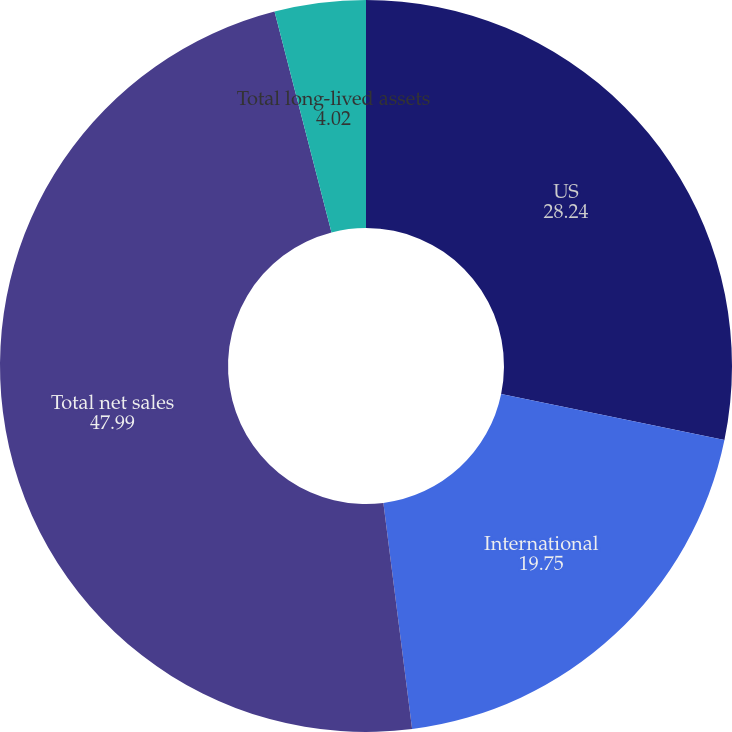Convert chart to OTSL. <chart><loc_0><loc_0><loc_500><loc_500><pie_chart><fcel>US<fcel>International<fcel>Total net sales<fcel>Total long-lived assets<nl><fcel>28.24%<fcel>19.75%<fcel>47.99%<fcel>4.02%<nl></chart> 